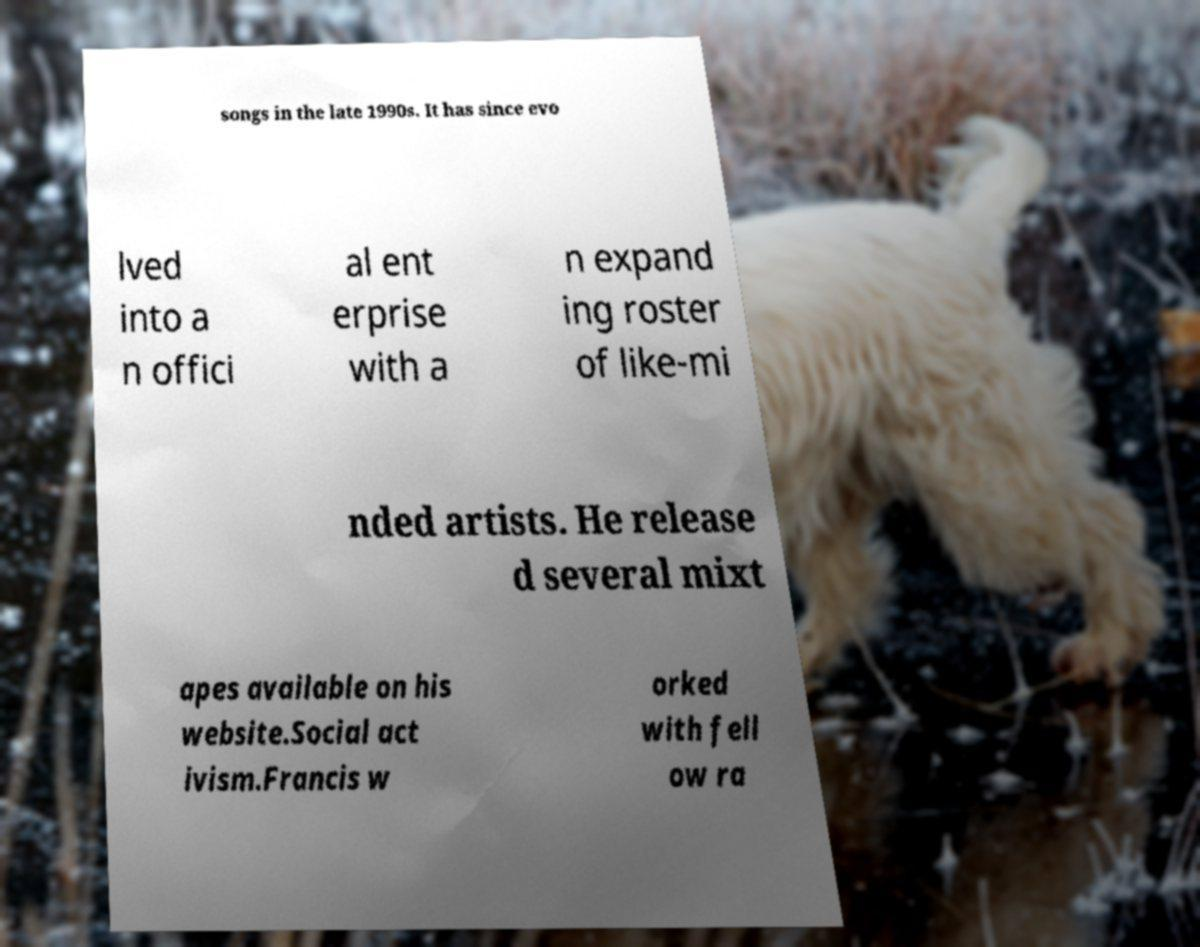Could you extract and type out the text from this image? songs in the late 1990s. It has since evo lved into a n offici al ent erprise with a n expand ing roster of like-mi nded artists. He release d several mixt apes available on his website.Social act ivism.Francis w orked with fell ow ra 